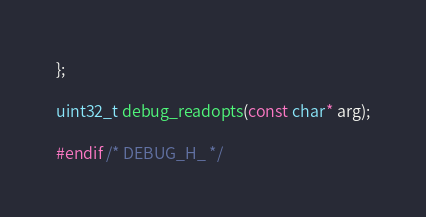<code> <loc_0><loc_0><loc_500><loc_500><_C_>};

uint32_t debug_readopts(const char* arg);

#endif /* DEBUG_H_ */
</code> 